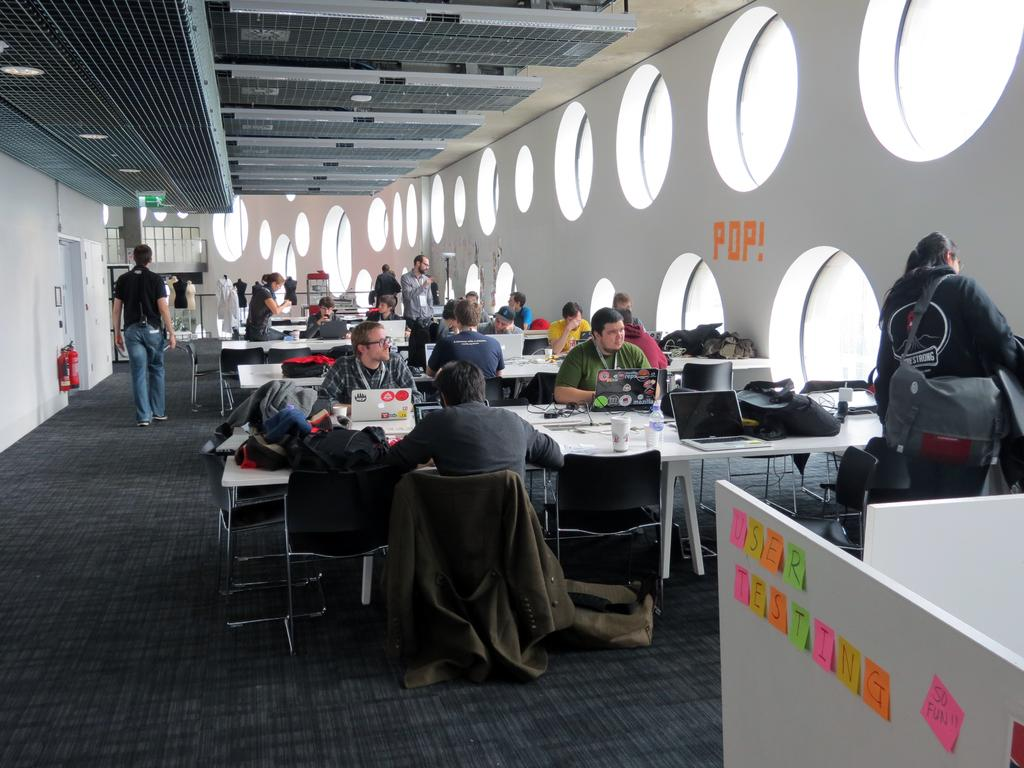Provide a one-sentence caption for the provided image. Notes on a wall that say there is testing going on. 